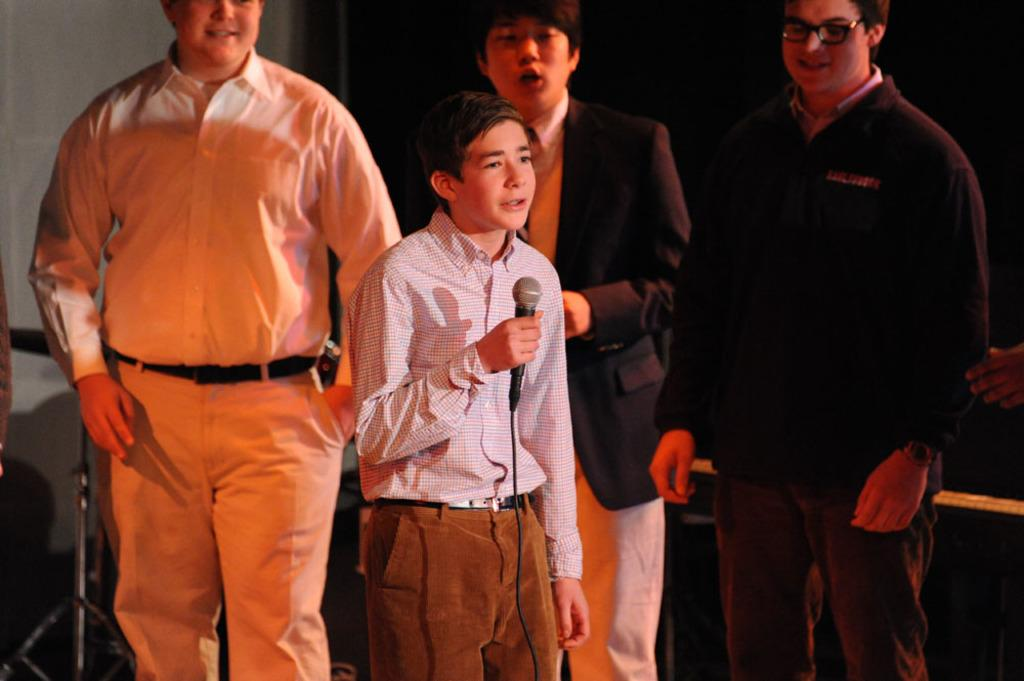How many people are in the image? There are people standing in the image. What is one of the people holding? One of the people is holding a microphone. What type of metal is the guitar made of in the image? There is no guitar present in the image. What feeling does the person holding the microphone have in the image? The image does not convey the feelings of the person holding the microphone, as it only shows their physical appearance and the object they are holding. 